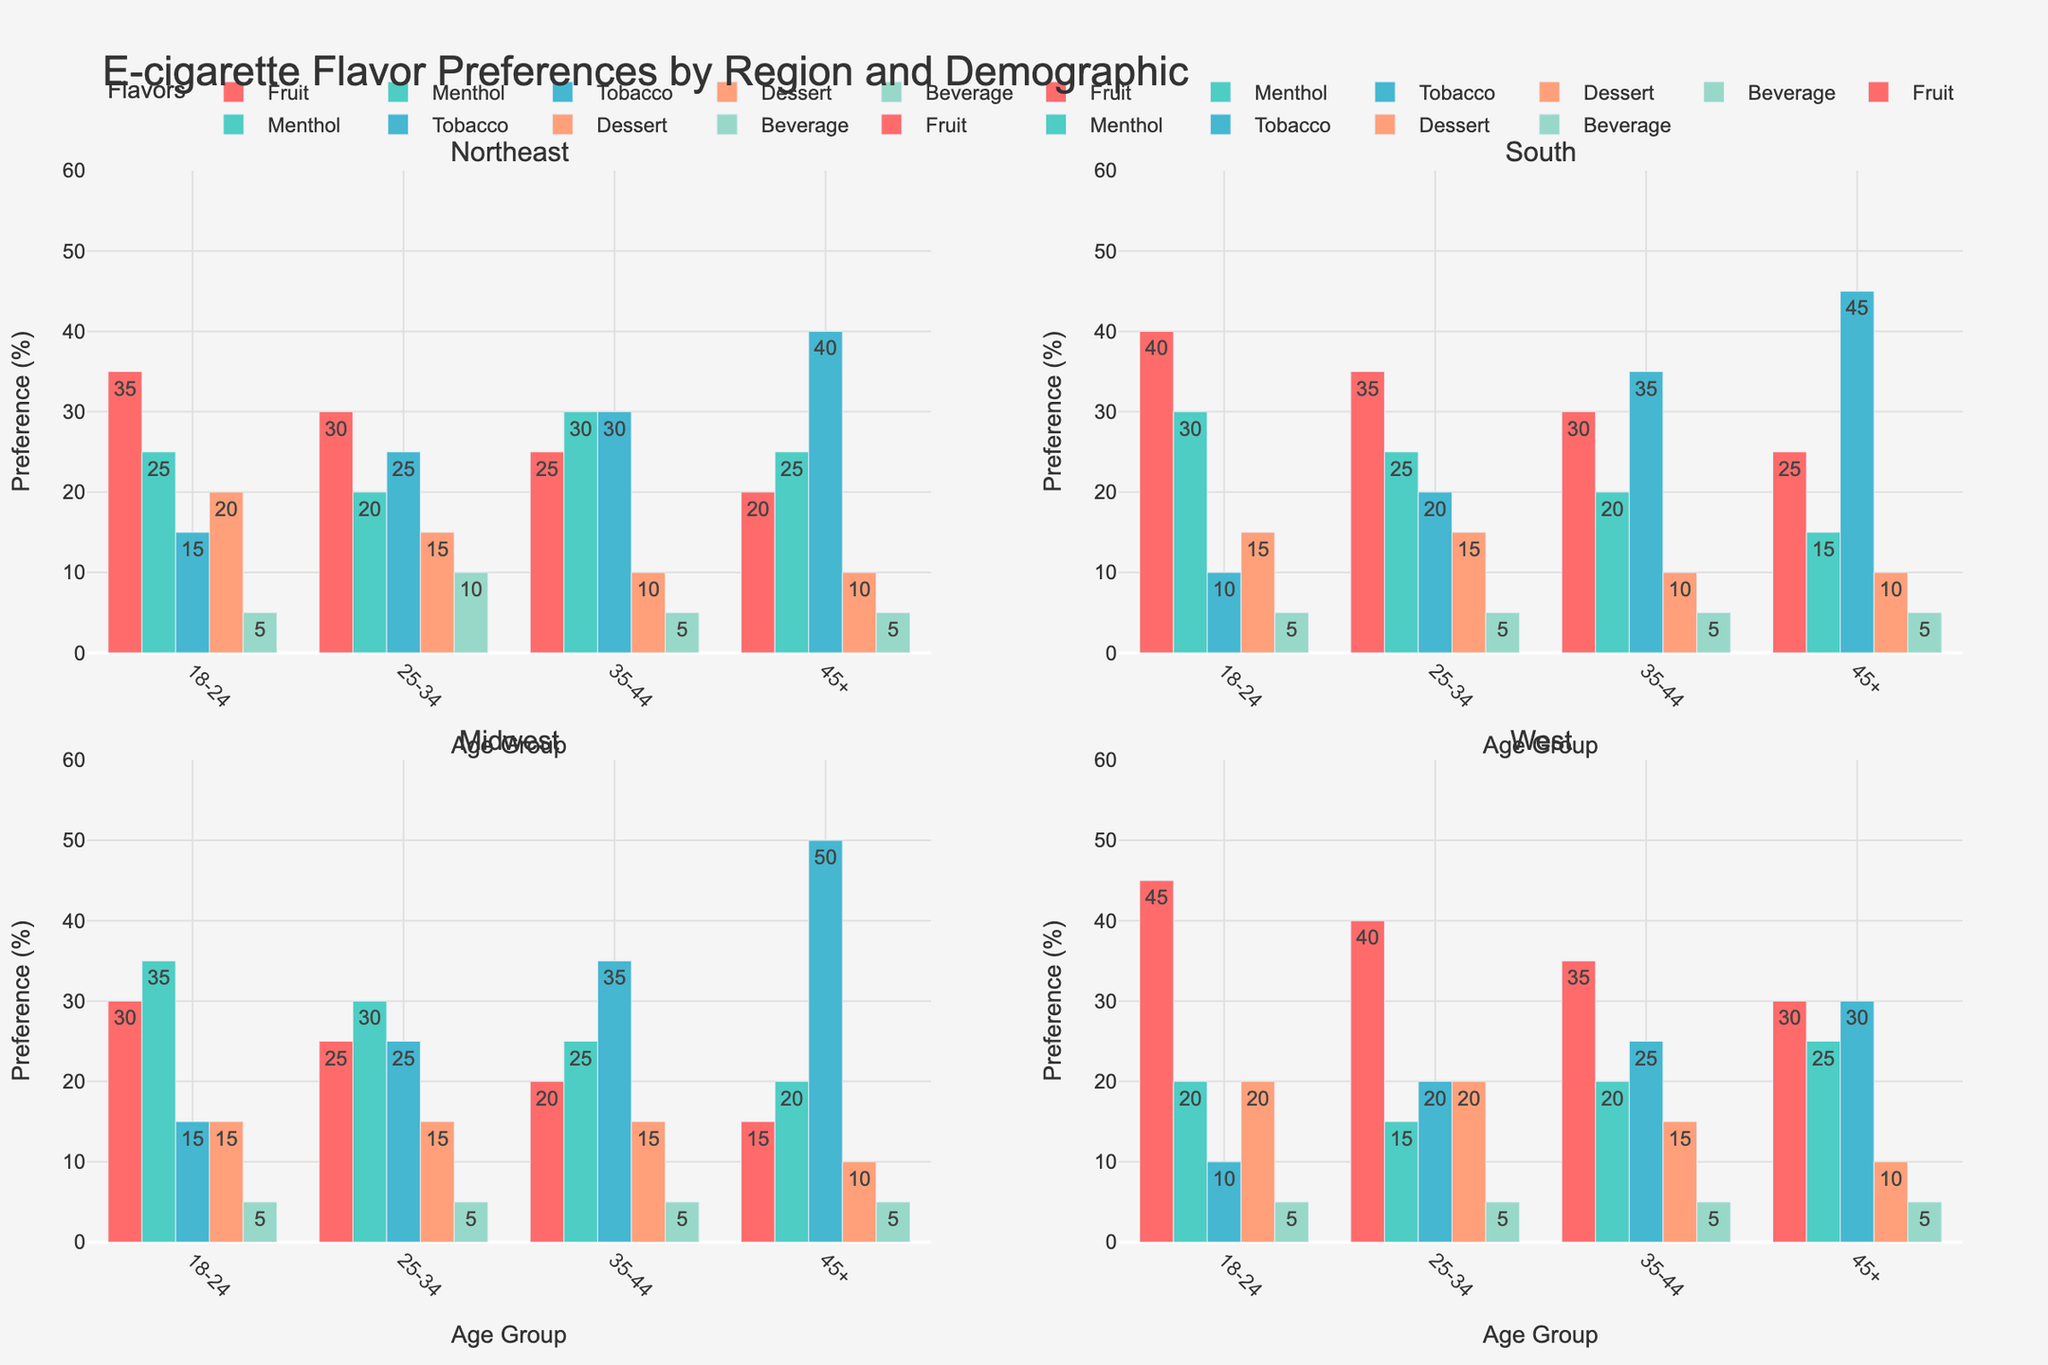Which region has the highest preference for Fruit flavored e-cigarettes among the 18-24 demographic? The figure shows the preference percentages for different flavors within each region. In the West region, the preference for Fruit flavor among the 18-24 demographic is 45%, the highest among all regions.
Answer: West What is the title of the figure? The title is displayed at the top of the figure, summarizing the information presented in it.
Answer: E-cigarette Flavor Preferences by Region and Demographic Among the 25-34 age group, which flavor has the lowest preference in the Midwest? Within the subplot for the Midwest region, the bar corresponding to Beverage for the 25-34 age group has the lowest height, indicating a 5% preference.
Answer: Beverage Compare the preference for Menthol flavor between the 35-44 demographic in the Northeast and the South. In the Northeast region, the preference for Menthol among the 35-44 demographic is 30%, whereas in the South region, it is 20%. Thus, the preference is higher in the Northeast by 10%.
Answer: Northeast Which demographic in the South has the highest preference for Tobacco flavored e-cigarettes? The bar chart for the South region shows that the 45+ age group has the highest preference for Tobacco flavor at 45%.
Answer: 45+ Between the 18-24 and 45+ demographics in the Midwest, which one has a higher preference for Dessert flavors, and by how much? In the Midwest region, the 18-24 demographic has a 15% preference for Dessert flavors, while the 45+ demographic has a 10% preference. The 18-24 demographic has a 5% higher preference.
Answer: 18-24 by 5% What is the preferred flavor for the 25-34 age group in the Northeast? In the Northeast region, among the 25-34 demographic, the Tobacco flavor has a 25% preference, which is the highest among the flavors.
Answer: Tobacco What is the common preference among all regions for the Beverage flavor across all demographics? All bars for Beverage flavor in each demographic across all regions are at the 5% preference level.
Answer: 5% How does the preference for Menthol flavor change as the age demographic increases in the West region? In the West region, the preference for Menthol flavor is 20% for 18-24, 15% for 25-34, 20% for 35-44, and 25% for 45+. It initially decreases and then increases.
Answer: Decreases then increases 